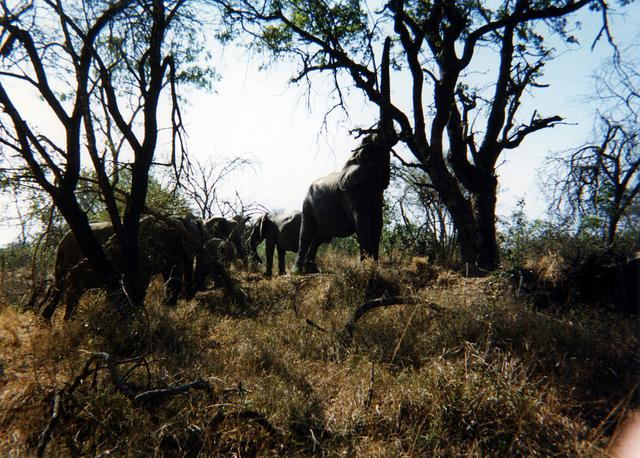In what setting are the animals? nature 